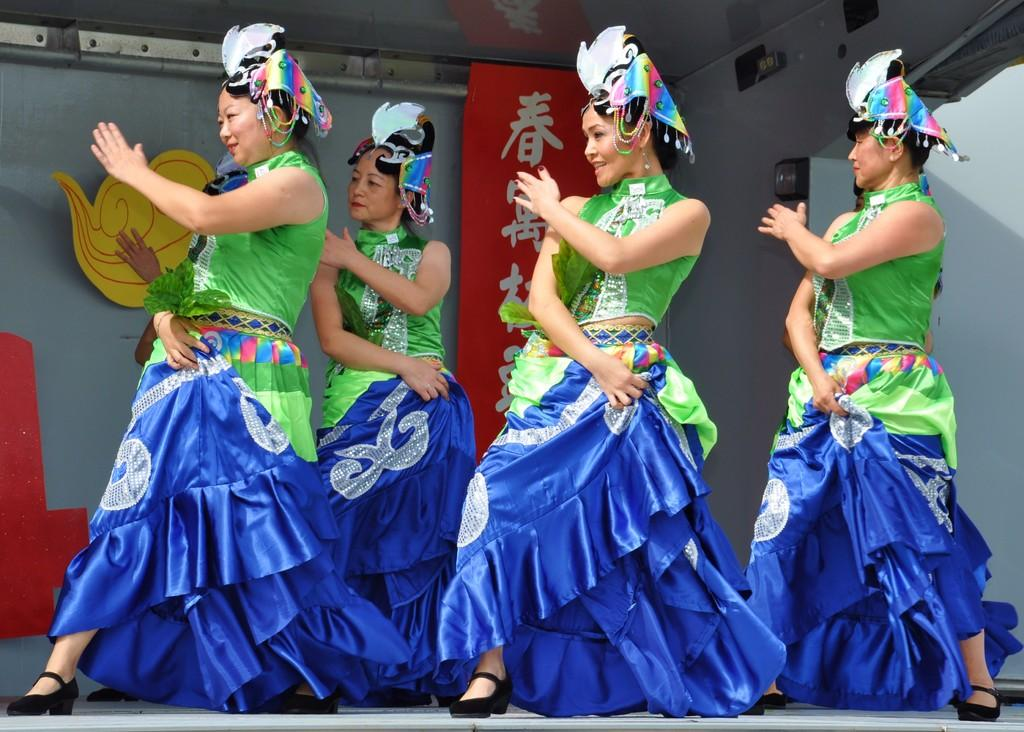What are the women in the image doing? The women are dancing on the stage. What can be seen in the background of the image? There is a name board and poles in the background, as well as other objects on the wall. What type of jail is visible in the background of the image? There is no jail present in the image; it features women dancing on a stage with a background that includes a name board, poles, and other objects on the wall. 